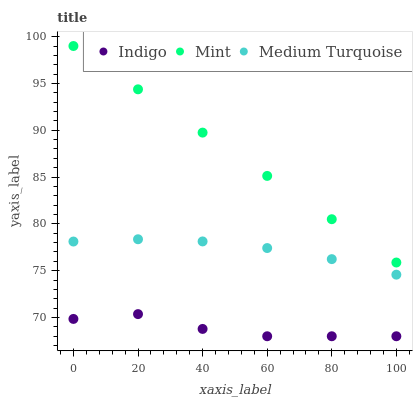Does Indigo have the minimum area under the curve?
Answer yes or no. Yes. Does Mint have the maximum area under the curve?
Answer yes or no. Yes. Does Medium Turquoise have the minimum area under the curve?
Answer yes or no. No. Does Medium Turquoise have the maximum area under the curve?
Answer yes or no. No. Is Mint the smoothest?
Answer yes or no. Yes. Is Indigo the roughest?
Answer yes or no. Yes. Is Medium Turquoise the smoothest?
Answer yes or no. No. Is Medium Turquoise the roughest?
Answer yes or no. No. Does Indigo have the lowest value?
Answer yes or no. Yes. Does Medium Turquoise have the lowest value?
Answer yes or no. No. Does Mint have the highest value?
Answer yes or no. Yes. Does Medium Turquoise have the highest value?
Answer yes or no. No. Is Indigo less than Mint?
Answer yes or no. Yes. Is Medium Turquoise greater than Indigo?
Answer yes or no. Yes. Does Indigo intersect Mint?
Answer yes or no. No. 